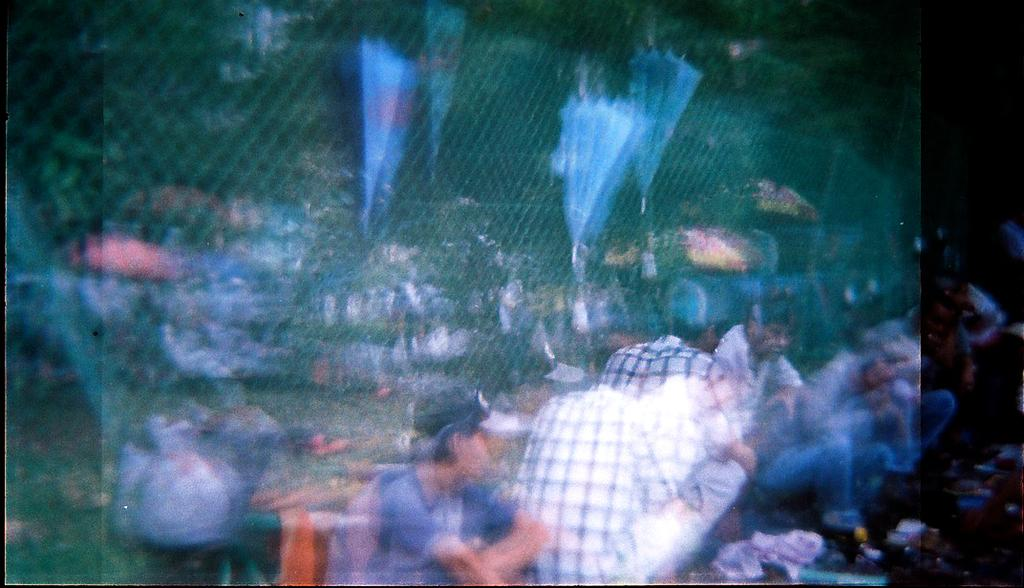Who or what can be seen in the image? There are people in the image. What objects are being used by the people in the image? There are umbrellas in the image. What type of natural environment is visible in the image? There are trees in the image. How would you describe the quality of the image? The image is blurred. Where is the throne located in the image? There is no throne present in the image. Can you provide an example of a street that can be seen in the image? There is no street visible in the image; it features people, umbrellas, and trees. 